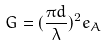<formula> <loc_0><loc_0><loc_500><loc_500>G = ( \frac { \pi d } { \lambda } ) ^ { 2 } e _ { A }</formula> 